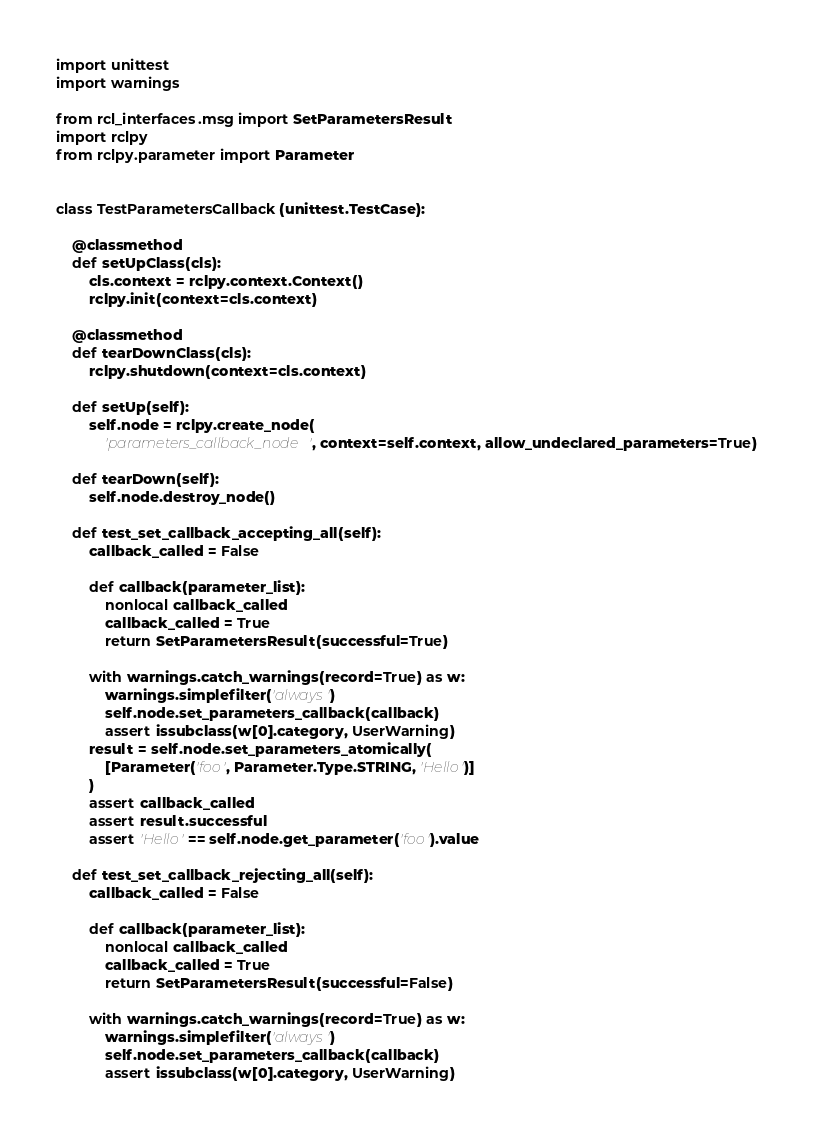Convert code to text. <code><loc_0><loc_0><loc_500><loc_500><_Python_>
import unittest
import warnings

from rcl_interfaces.msg import SetParametersResult
import rclpy
from rclpy.parameter import Parameter


class TestParametersCallback(unittest.TestCase):

    @classmethod
    def setUpClass(cls):
        cls.context = rclpy.context.Context()
        rclpy.init(context=cls.context)

    @classmethod
    def tearDownClass(cls):
        rclpy.shutdown(context=cls.context)

    def setUp(self):
        self.node = rclpy.create_node(
            'parameters_callback_node', context=self.context, allow_undeclared_parameters=True)

    def tearDown(self):
        self.node.destroy_node()

    def test_set_callback_accepting_all(self):
        callback_called = False

        def callback(parameter_list):
            nonlocal callback_called
            callback_called = True
            return SetParametersResult(successful=True)

        with warnings.catch_warnings(record=True) as w:
            warnings.simplefilter('always')
            self.node.set_parameters_callback(callback)
            assert issubclass(w[0].category, UserWarning)
        result = self.node.set_parameters_atomically(
            [Parameter('foo', Parameter.Type.STRING, 'Hello')]
        )
        assert callback_called
        assert result.successful
        assert 'Hello' == self.node.get_parameter('foo').value

    def test_set_callback_rejecting_all(self):
        callback_called = False

        def callback(parameter_list):
            nonlocal callback_called
            callback_called = True
            return SetParametersResult(successful=False)

        with warnings.catch_warnings(record=True) as w:
            warnings.simplefilter('always')
            self.node.set_parameters_callback(callback)
            assert issubclass(w[0].category, UserWarning)</code> 